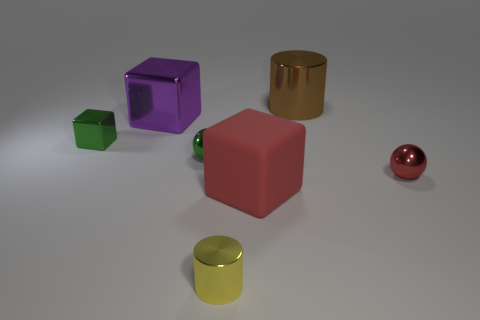What is the material of the thing that is to the right of the small yellow cylinder and behind the small red ball? The object to the right of the small yellow cylinder and behind the small red ball appears to be a purple cube, likely made of a plastic or a similarly smooth, slightly reflective material. 